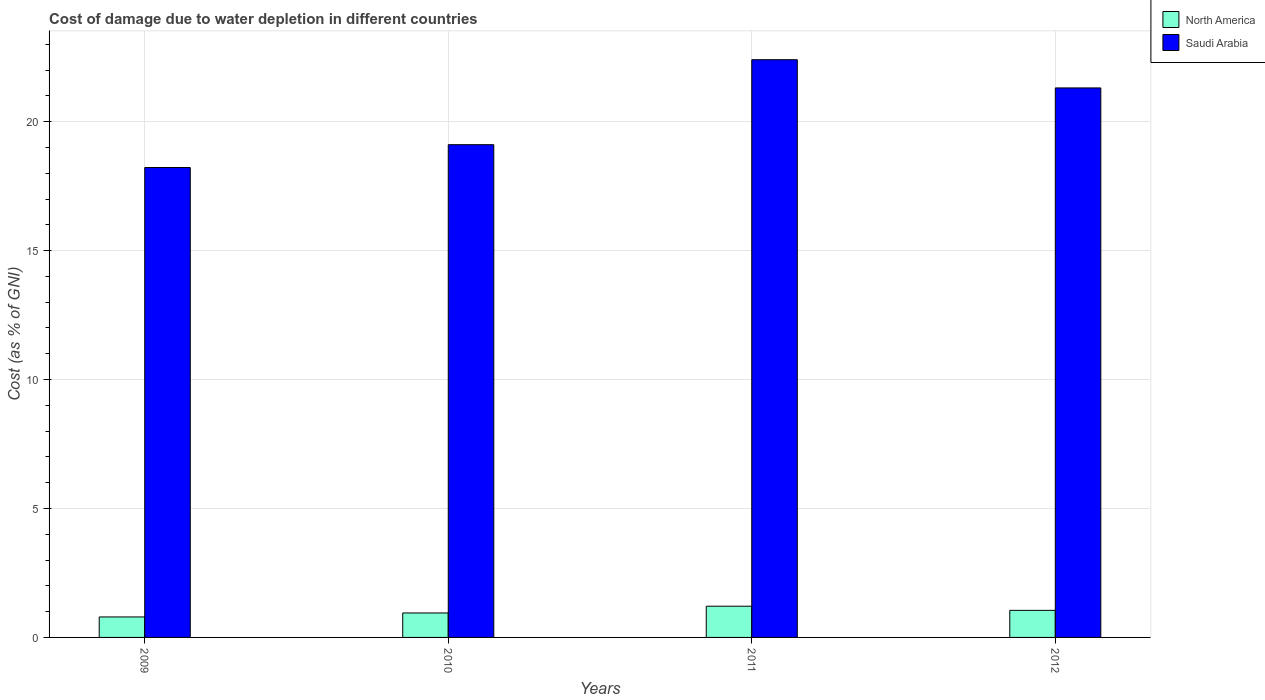How many different coloured bars are there?
Your answer should be very brief. 2. How many groups of bars are there?
Provide a succinct answer. 4. Are the number of bars per tick equal to the number of legend labels?
Your answer should be very brief. Yes. Are the number of bars on each tick of the X-axis equal?
Ensure brevity in your answer.  Yes. What is the label of the 1st group of bars from the left?
Your answer should be compact. 2009. What is the cost of damage caused due to water depletion in North America in 2010?
Keep it short and to the point. 0.95. Across all years, what is the maximum cost of damage caused due to water depletion in North America?
Keep it short and to the point. 1.21. Across all years, what is the minimum cost of damage caused due to water depletion in North America?
Your answer should be very brief. 0.79. In which year was the cost of damage caused due to water depletion in North America minimum?
Your response must be concise. 2009. What is the total cost of damage caused due to water depletion in North America in the graph?
Give a very brief answer. 4. What is the difference between the cost of damage caused due to water depletion in North America in 2009 and that in 2012?
Your answer should be very brief. -0.26. What is the difference between the cost of damage caused due to water depletion in Saudi Arabia in 2011 and the cost of damage caused due to water depletion in North America in 2012?
Your answer should be compact. 21.35. What is the average cost of damage caused due to water depletion in North America per year?
Provide a succinct answer. 1. In the year 2012, what is the difference between the cost of damage caused due to water depletion in North America and cost of damage caused due to water depletion in Saudi Arabia?
Your response must be concise. -20.26. What is the ratio of the cost of damage caused due to water depletion in North America in 2010 to that in 2012?
Your response must be concise. 0.9. Is the cost of damage caused due to water depletion in North America in 2010 less than that in 2011?
Your answer should be very brief. Yes. Is the difference between the cost of damage caused due to water depletion in North America in 2010 and 2012 greater than the difference between the cost of damage caused due to water depletion in Saudi Arabia in 2010 and 2012?
Offer a very short reply. Yes. What is the difference between the highest and the second highest cost of damage caused due to water depletion in North America?
Offer a terse response. 0.16. What is the difference between the highest and the lowest cost of damage caused due to water depletion in Saudi Arabia?
Your response must be concise. 4.18. In how many years, is the cost of damage caused due to water depletion in North America greater than the average cost of damage caused due to water depletion in North America taken over all years?
Provide a succinct answer. 2. Is the sum of the cost of damage caused due to water depletion in North America in 2009 and 2010 greater than the maximum cost of damage caused due to water depletion in Saudi Arabia across all years?
Make the answer very short. No. What does the 2nd bar from the left in 2009 represents?
Your answer should be compact. Saudi Arabia. What does the 1st bar from the right in 2012 represents?
Offer a very short reply. Saudi Arabia. Are all the bars in the graph horizontal?
Provide a short and direct response. No. How many years are there in the graph?
Offer a very short reply. 4. What is the difference between two consecutive major ticks on the Y-axis?
Your response must be concise. 5. Are the values on the major ticks of Y-axis written in scientific E-notation?
Provide a short and direct response. No. What is the title of the graph?
Provide a succinct answer. Cost of damage due to water depletion in different countries. What is the label or title of the Y-axis?
Keep it short and to the point. Cost (as % of GNI). What is the Cost (as % of GNI) in North America in 2009?
Provide a short and direct response. 0.79. What is the Cost (as % of GNI) of Saudi Arabia in 2009?
Give a very brief answer. 18.22. What is the Cost (as % of GNI) in North America in 2010?
Your answer should be compact. 0.95. What is the Cost (as % of GNI) of Saudi Arabia in 2010?
Your answer should be very brief. 19.11. What is the Cost (as % of GNI) of North America in 2011?
Make the answer very short. 1.21. What is the Cost (as % of GNI) in Saudi Arabia in 2011?
Your answer should be very brief. 22.4. What is the Cost (as % of GNI) of North America in 2012?
Your response must be concise. 1.05. What is the Cost (as % of GNI) in Saudi Arabia in 2012?
Your response must be concise. 21.31. Across all years, what is the maximum Cost (as % of GNI) of North America?
Keep it short and to the point. 1.21. Across all years, what is the maximum Cost (as % of GNI) of Saudi Arabia?
Your response must be concise. 22.4. Across all years, what is the minimum Cost (as % of GNI) in North America?
Keep it short and to the point. 0.79. Across all years, what is the minimum Cost (as % of GNI) of Saudi Arabia?
Ensure brevity in your answer.  18.22. What is the total Cost (as % of GNI) of North America in the graph?
Give a very brief answer. 4. What is the total Cost (as % of GNI) in Saudi Arabia in the graph?
Your answer should be compact. 81.04. What is the difference between the Cost (as % of GNI) of North America in 2009 and that in 2010?
Make the answer very short. -0.15. What is the difference between the Cost (as % of GNI) in Saudi Arabia in 2009 and that in 2010?
Provide a short and direct response. -0.89. What is the difference between the Cost (as % of GNI) in North America in 2009 and that in 2011?
Provide a succinct answer. -0.42. What is the difference between the Cost (as % of GNI) in Saudi Arabia in 2009 and that in 2011?
Provide a succinct answer. -4.18. What is the difference between the Cost (as % of GNI) in North America in 2009 and that in 2012?
Offer a terse response. -0.26. What is the difference between the Cost (as % of GNI) of Saudi Arabia in 2009 and that in 2012?
Make the answer very short. -3.09. What is the difference between the Cost (as % of GNI) in North America in 2010 and that in 2011?
Your answer should be very brief. -0.26. What is the difference between the Cost (as % of GNI) of Saudi Arabia in 2010 and that in 2011?
Ensure brevity in your answer.  -3.29. What is the difference between the Cost (as % of GNI) in North America in 2010 and that in 2012?
Make the answer very short. -0.1. What is the difference between the Cost (as % of GNI) in Saudi Arabia in 2010 and that in 2012?
Give a very brief answer. -2.2. What is the difference between the Cost (as % of GNI) of North America in 2011 and that in 2012?
Offer a very short reply. 0.16. What is the difference between the Cost (as % of GNI) in Saudi Arabia in 2011 and that in 2012?
Make the answer very short. 1.09. What is the difference between the Cost (as % of GNI) in North America in 2009 and the Cost (as % of GNI) in Saudi Arabia in 2010?
Your answer should be very brief. -18.31. What is the difference between the Cost (as % of GNI) in North America in 2009 and the Cost (as % of GNI) in Saudi Arabia in 2011?
Make the answer very short. -21.61. What is the difference between the Cost (as % of GNI) of North America in 2009 and the Cost (as % of GNI) of Saudi Arabia in 2012?
Give a very brief answer. -20.51. What is the difference between the Cost (as % of GNI) of North America in 2010 and the Cost (as % of GNI) of Saudi Arabia in 2011?
Your answer should be very brief. -21.45. What is the difference between the Cost (as % of GNI) of North America in 2010 and the Cost (as % of GNI) of Saudi Arabia in 2012?
Offer a terse response. -20.36. What is the difference between the Cost (as % of GNI) in North America in 2011 and the Cost (as % of GNI) in Saudi Arabia in 2012?
Give a very brief answer. -20.1. What is the average Cost (as % of GNI) of North America per year?
Provide a short and direct response. 1. What is the average Cost (as % of GNI) of Saudi Arabia per year?
Your response must be concise. 20.26. In the year 2009, what is the difference between the Cost (as % of GNI) of North America and Cost (as % of GNI) of Saudi Arabia?
Offer a very short reply. -17.43. In the year 2010, what is the difference between the Cost (as % of GNI) of North America and Cost (as % of GNI) of Saudi Arabia?
Provide a short and direct response. -18.16. In the year 2011, what is the difference between the Cost (as % of GNI) of North America and Cost (as % of GNI) of Saudi Arabia?
Your answer should be compact. -21.19. In the year 2012, what is the difference between the Cost (as % of GNI) in North America and Cost (as % of GNI) in Saudi Arabia?
Offer a very short reply. -20.26. What is the ratio of the Cost (as % of GNI) in North America in 2009 to that in 2010?
Give a very brief answer. 0.84. What is the ratio of the Cost (as % of GNI) in Saudi Arabia in 2009 to that in 2010?
Keep it short and to the point. 0.95. What is the ratio of the Cost (as % of GNI) in North America in 2009 to that in 2011?
Provide a succinct answer. 0.66. What is the ratio of the Cost (as % of GNI) in Saudi Arabia in 2009 to that in 2011?
Keep it short and to the point. 0.81. What is the ratio of the Cost (as % of GNI) in North America in 2009 to that in 2012?
Offer a very short reply. 0.76. What is the ratio of the Cost (as % of GNI) of Saudi Arabia in 2009 to that in 2012?
Your answer should be compact. 0.86. What is the ratio of the Cost (as % of GNI) in North America in 2010 to that in 2011?
Ensure brevity in your answer.  0.78. What is the ratio of the Cost (as % of GNI) of Saudi Arabia in 2010 to that in 2011?
Make the answer very short. 0.85. What is the ratio of the Cost (as % of GNI) of North America in 2010 to that in 2012?
Provide a short and direct response. 0.9. What is the ratio of the Cost (as % of GNI) in Saudi Arabia in 2010 to that in 2012?
Give a very brief answer. 0.9. What is the ratio of the Cost (as % of GNI) of North America in 2011 to that in 2012?
Make the answer very short. 1.15. What is the ratio of the Cost (as % of GNI) of Saudi Arabia in 2011 to that in 2012?
Your answer should be compact. 1.05. What is the difference between the highest and the second highest Cost (as % of GNI) in North America?
Give a very brief answer. 0.16. What is the difference between the highest and the second highest Cost (as % of GNI) in Saudi Arabia?
Provide a short and direct response. 1.09. What is the difference between the highest and the lowest Cost (as % of GNI) in North America?
Give a very brief answer. 0.42. What is the difference between the highest and the lowest Cost (as % of GNI) in Saudi Arabia?
Keep it short and to the point. 4.18. 